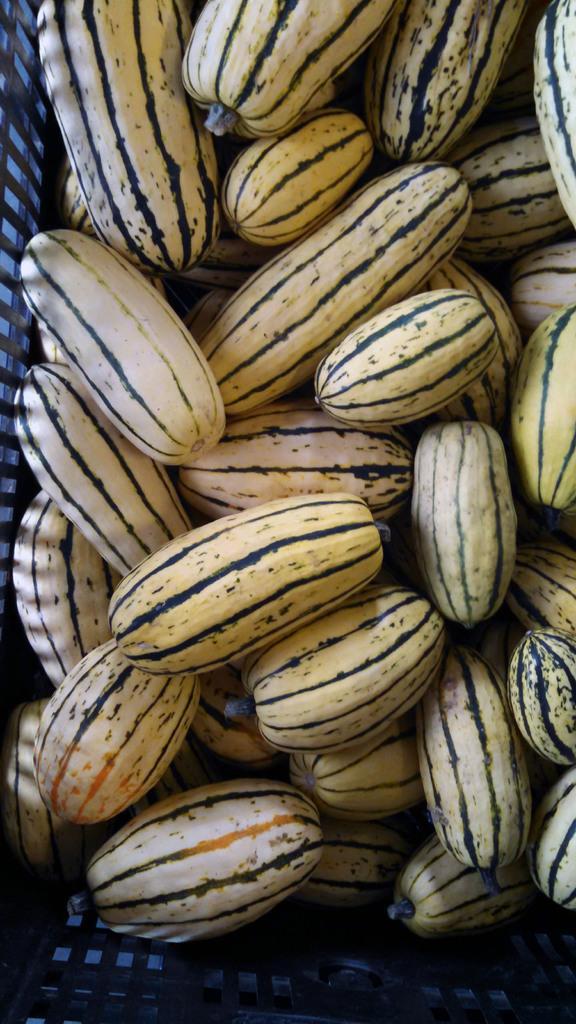Describe this image in one or two sentences. In this picture we can see fruits. 